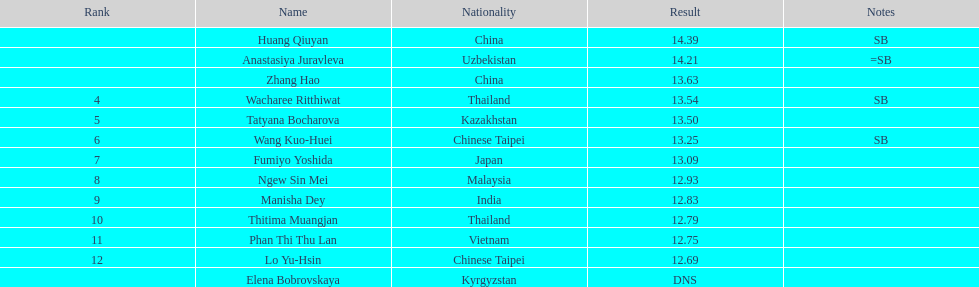How many points apart were the 1st place competitor and the 12th place competitor? 1.7. 